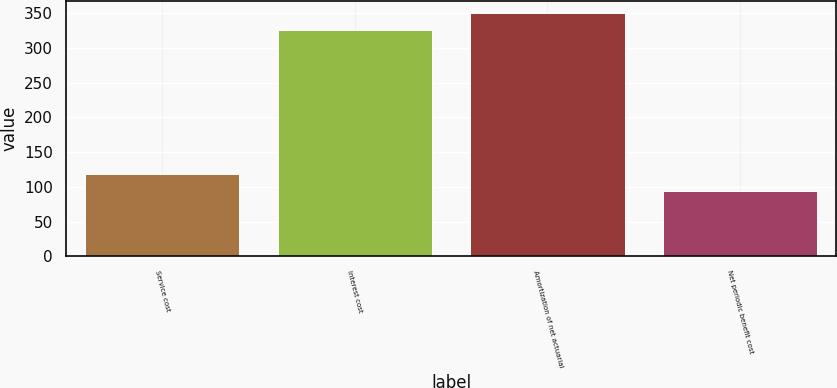Convert chart. <chart><loc_0><loc_0><loc_500><loc_500><bar_chart><fcel>Service cost<fcel>Interest cost<fcel>Amortization of net actuarial<fcel>Net periodic benefit cost<nl><fcel>117.9<fcel>326<fcel>349.9<fcel>94<nl></chart> 